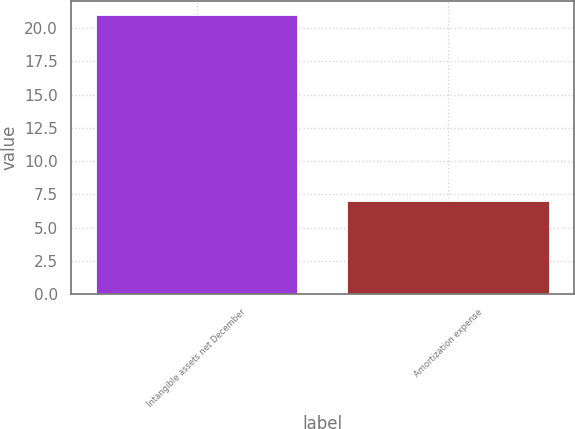Convert chart to OTSL. <chart><loc_0><loc_0><loc_500><loc_500><bar_chart><fcel>Intangible assets net December<fcel>Amortization expense<nl><fcel>21<fcel>7<nl></chart> 